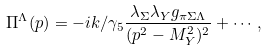<formula> <loc_0><loc_0><loc_500><loc_500>\Pi ^ { \Lambda } ( p ) = - i k / \gamma _ { 5 } { \frac { \lambda _ { \Sigma } \lambda _ { Y } g _ { \pi \Sigma \Lambda } } { ( p ^ { 2 } - M _ { Y } ^ { 2 } ) ^ { 2 } } } + \cdots ,</formula> 